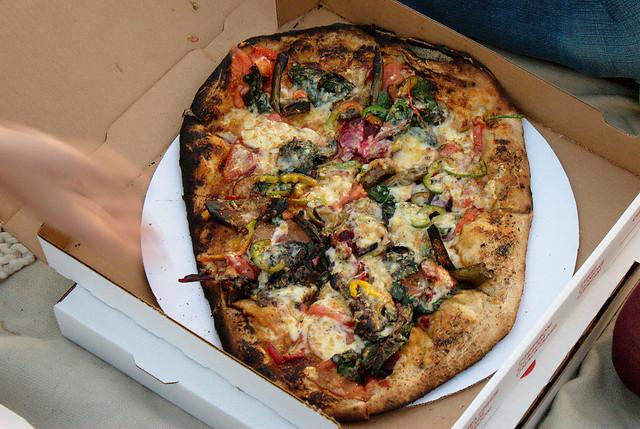What is blurred in photo?
Concise answer only. Hand. Is the pizza burnt?
Concise answer only. Yes. Has anyone taking a bite of the pizza yet?
Write a very short answer. No. 